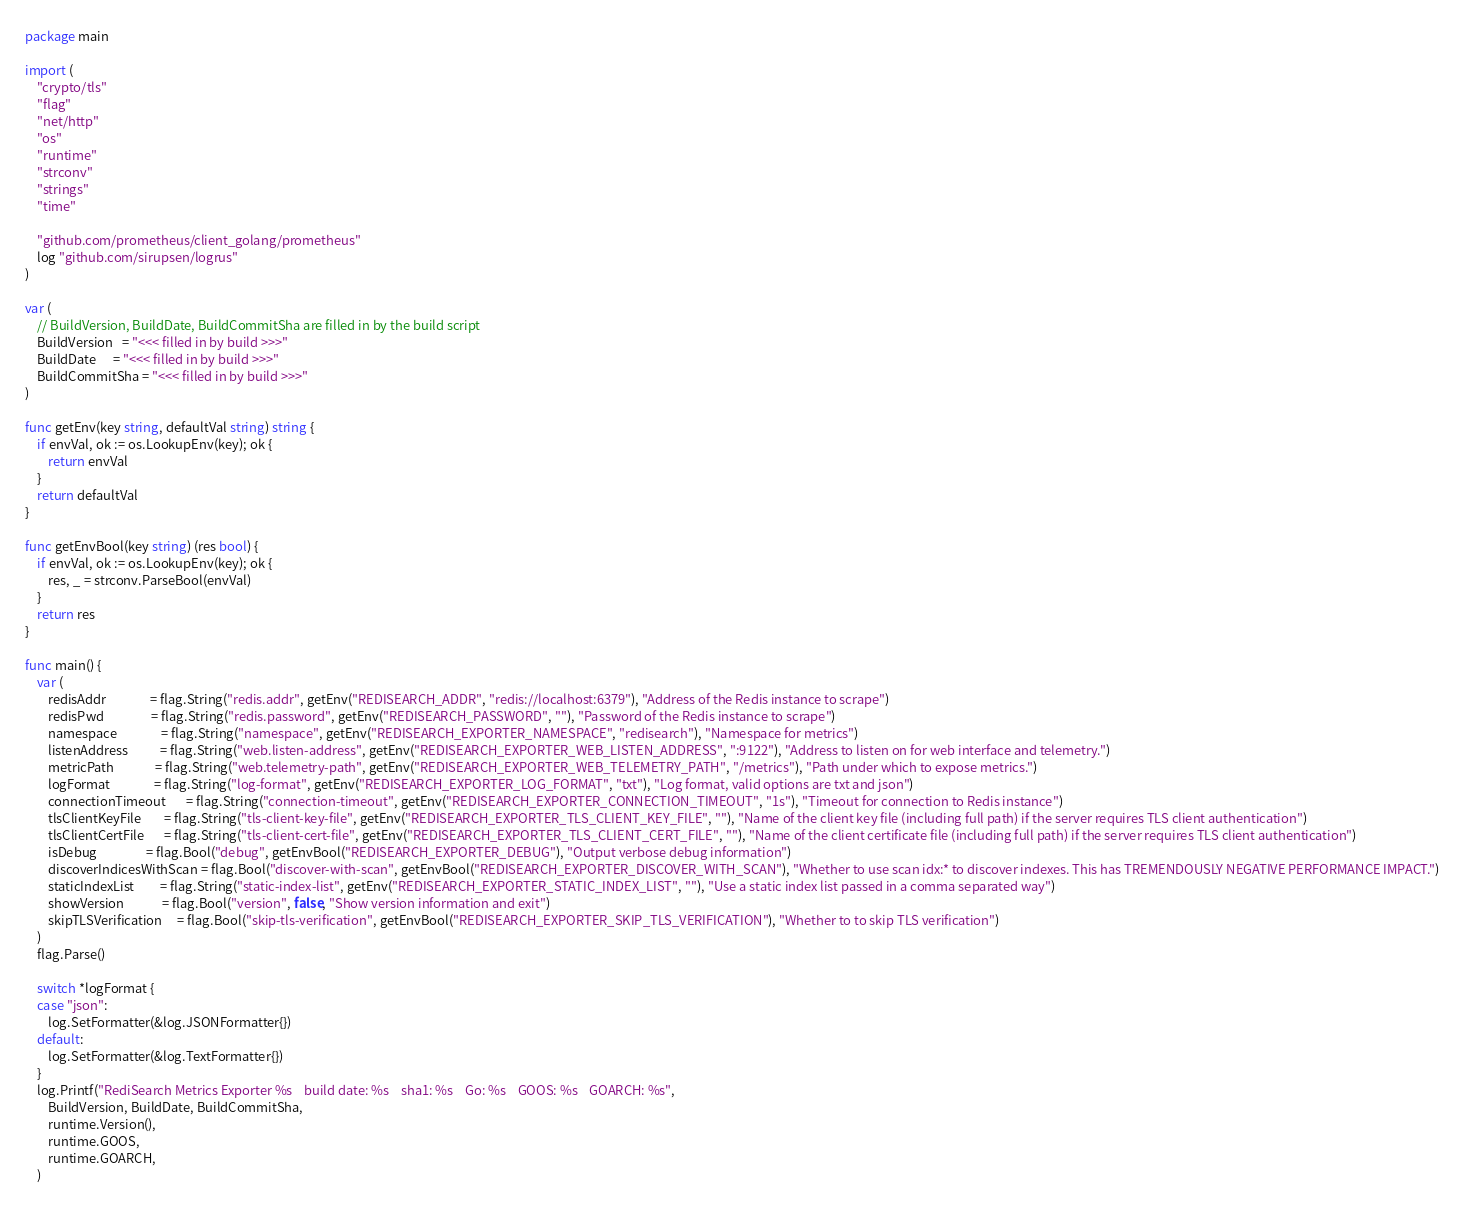<code> <loc_0><loc_0><loc_500><loc_500><_Go_>package main

import (
	"crypto/tls"
	"flag"
	"net/http"
	"os"
	"runtime"
	"strconv"
	"strings"
	"time"

	"github.com/prometheus/client_golang/prometheus"
	log "github.com/sirupsen/logrus"
)

var (
	// BuildVersion, BuildDate, BuildCommitSha are filled in by the build script
	BuildVersion   = "<<< filled in by build >>>"
	BuildDate      = "<<< filled in by build >>>"
	BuildCommitSha = "<<< filled in by build >>>"
)

func getEnv(key string, defaultVal string) string {
	if envVal, ok := os.LookupEnv(key); ok {
		return envVal
	}
	return defaultVal
}

func getEnvBool(key string) (res bool) {
	if envVal, ok := os.LookupEnv(key); ok {
		res, _ = strconv.ParseBool(envVal)
	}
	return res
}

func main() {
	var (
		redisAddr               = flag.String("redis.addr", getEnv("REDISEARCH_ADDR", "redis://localhost:6379"), "Address of the Redis instance to scrape")
		redisPwd                = flag.String("redis.password", getEnv("REDISEARCH_PASSWORD", ""), "Password of the Redis instance to scrape")
		namespace               = flag.String("namespace", getEnv("REDISEARCH_EXPORTER_NAMESPACE", "redisearch"), "Namespace for metrics")
		listenAddress           = flag.String("web.listen-address", getEnv("REDISEARCH_EXPORTER_WEB_LISTEN_ADDRESS", ":9122"), "Address to listen on for web interface and telemetry.")
		metricPath              = flag.String("web.telemetry-path", getEnv("REDISEARCH_EXPORTER_WEB_TELEMETRY_PATH", "/metrics"), "Path under which to expose metrics.")
		logFormat               = flag.String("log-format", getEnv("REDISEARCH_EXPORTER_LOG_FORMAT", "txt"), "Log format, valid options are txt and json")
		connectionTimeout       = flag.String("connection-timeout", getEnv("REDISEARCH_EXPORTER_CONNECTION_TIMEOUT", "1s"), "Timeout for connection to Redis instance")
		tlsClientKeyFile        = flag.String("tls-client-key-file", getEnv("REDISEARCH_EXPORTER_TLS_CLIENT_KEY_FILE", ""), "Name of the client key file (including full path) if the server requires TLS client authentication")
		tlsClientCertFile       = flag.String("tls-client-cert-file", getEnv("REDISEARCH_EXPORTER_TLS_CLIENT_CERT_FILE", ""), "Name of the client certificate file (including full path) if the server requires TLS client authentication")
		isDebug                 = flag.Bool("debug", getEnvBool("REDISEARCH_EXPORTER_DEBUG"), "Output verbose debug information")
		discoverIndicesWithScan = flag.Bool("discover-with-scan", getEnvBool("REDISEARCH_EXPORTER_DISCOVER_WITH_SCAN"), "Whether to use scan idx:* to discover indexes. This has TREMENDOUSLY NEGATIVE PERFORMANCE IMPACT.")
		staticIndexList         = flag.String("static-index-list", getEnv("REDISEARCH_EXPORTER_STATIC_INDEX_LIST", ""), "Use a static index list passed in a comma separated way")
		showVersion             = flag.Bool("version", false, "Show version information and exit")
		skipTLSVerification     = flag.Bool("skip-tls-verification", getEnvBool("REDISEARCH_EXPORTER_SKIP_TLS_VERIFICATION"), "Whether to to skip TLS verification")
	)
	flag.Parse()

	switch *logFormat {
	case "json":
		log.SetFormatter(&log.JSONFormatter{})
	default:
		log.SetFormatter(&log.TextFormatter{})
	}
	log.Printf("RediSearch Metrics Exporter %s    build date: %s    sha1: %s    Go: %s    GOOS: %s    GOARCH: %s",
		BuildVersion, BuildDate, BuildCommitSha,
		runtime.Version(),
		runtime.GOOS,
		runtime.GOARCH,
	)</code> 